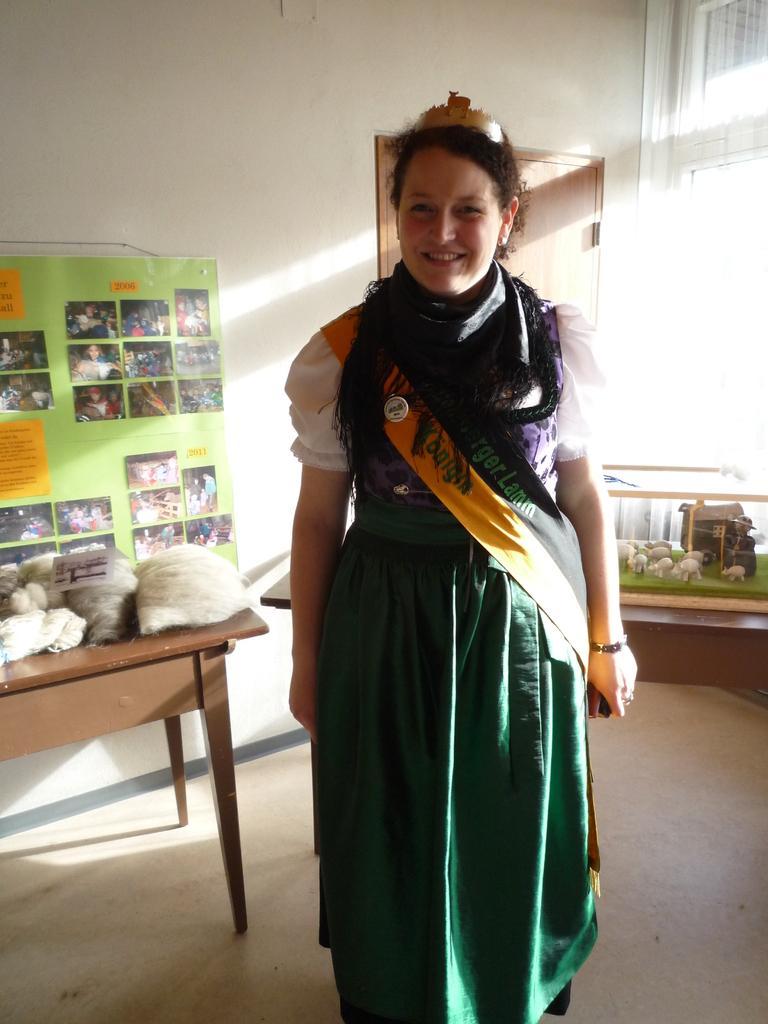Can you describe this image briefly? In this picture we can see woman standing and smiling and in background we can see table and on table there are some clothes, poster to the wall, door, window, toys. 